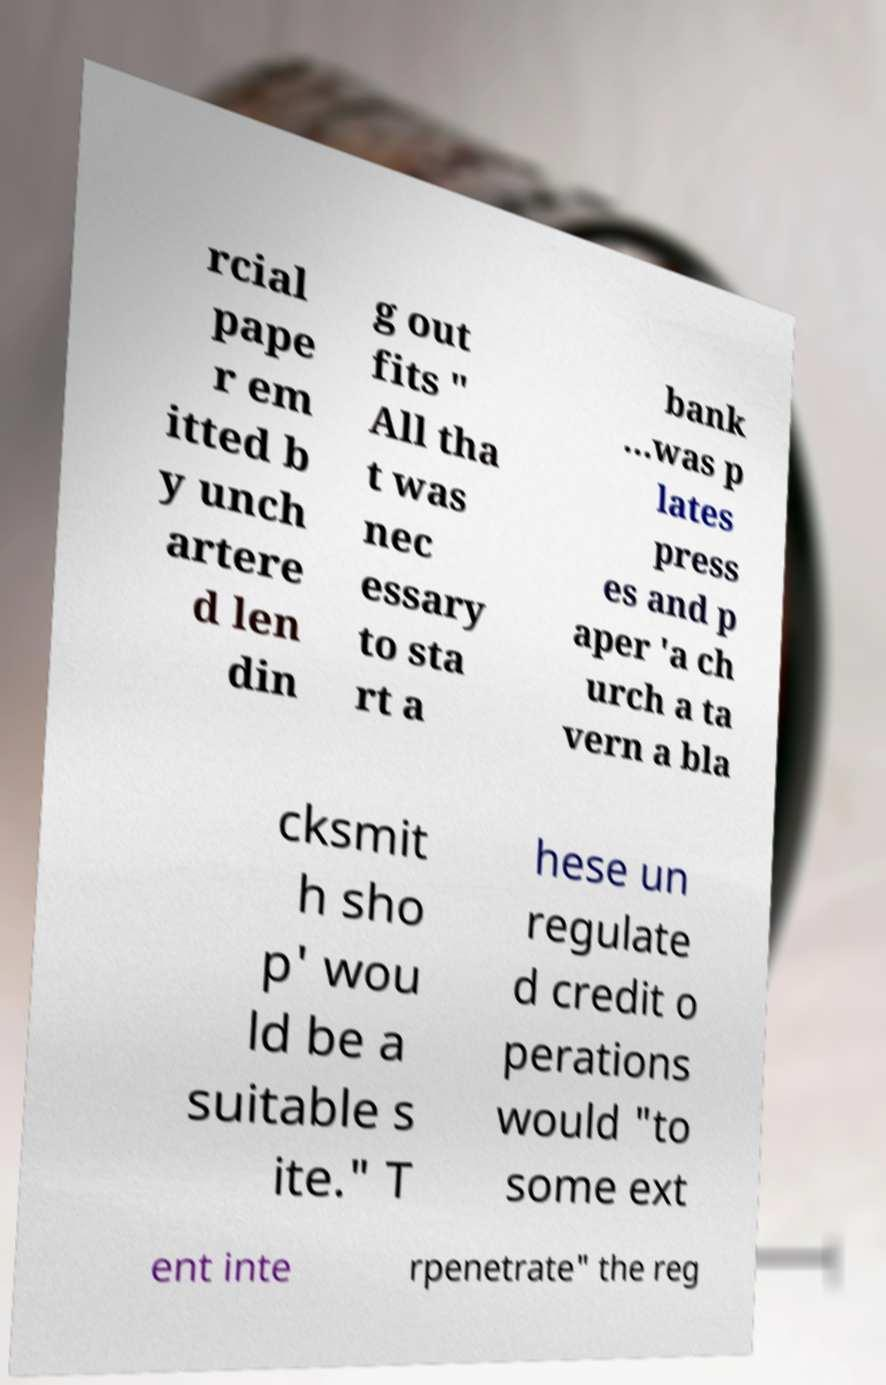Could you assist in decoding the text presented in this image and type it out clearly? rcial pape r em itted b y unch artere d len din g out fits " All tha t was nec essary to sta rt a bank …was p lates press es and p aper 'a ch urch a ta vern a bla cksmit h sho p' wou ld be a suitable s ite." T hese un regulate d credit o perations would "to some ext ent inte rpenetrate" the reg 